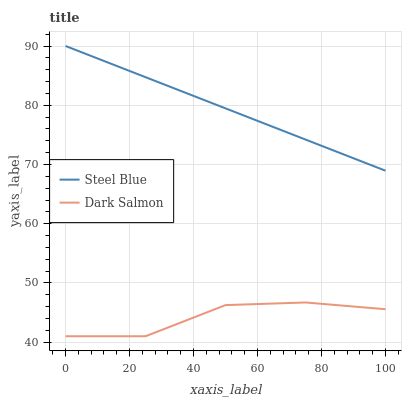Does Dark Salmon have the minimum area under the curve?
Answer yes or no. Yes. Does Steel Blue have the maximum area under the curve?
Answer yes or no. Yes. Does Dark Salmon have the maximum area under the curve?
Answer yes or no. No. Is Steel Blue the smoothest?
Answer yes or no. Yes. Is Dark Salmon the roughest?
Answer yes or no. Yes. Is Dark Salmon the smoothest?
Answer yes or no. No. Does Dark Salmon have the lowest value?
Answer yes or no. Yes. Does Steel Blue have the highest value?
Answer yes or no. Yes. Does Dark Salmon have the highest value?
Answer yes or no. No. Is Dark Salmon less than Steel Blue?
Answer yes or no. Yes. Is Steel Blue greater than Dark Salmon?
Answer yes or no. Yes. Does Dark Salmon intersect Steel Blue?
Answer yes or no. No. 